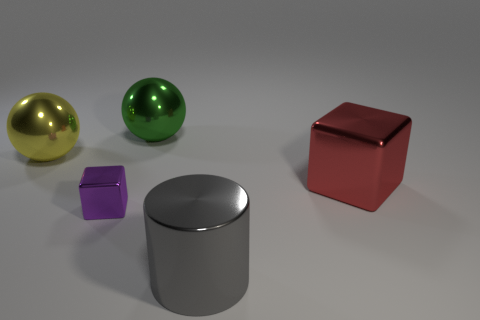There is a metallic ball that is on the right side of the big yellow metal object; is its size the same as the block behind the tiny purple metal block?
Give a very brief answer. Yes. The big object behind the ball that is to the left of the large green metallic thing is made of what material?
Offer a terse response. Metal. What number of objects are either large metallic objects left of the big green sphere or purple metal things?
Provide a succinct answer. 2. Is the number of green metal objects that are in front of the purple thing the same as the number of metal spheres in front of the large yellow ball?
Ensure brevity in your answer.  Yes. There is a cube to the left of the sphere on the right side of the yellow sphere behind the small purple shiny thing; what is its material?
Offer a very short reply. Metal. There is a metallic thing that is in front of the yellow thing and left of the cylinder; what is its size?
Provide a succinct answer. Small. Is the big yellow shiny thing the same shape as the tiny object?
Your response must be concise. No. The big green object that is made of the same material as the purple object is what shape?
Your response must be concise. Sphere. How many big objects are yellow balls or red metal blocks?
Make the answer very short. 2. There is a big gray cylinder left of the large shiny block; is there a cylinder that is in front of it?
Offer a terse response. No. 